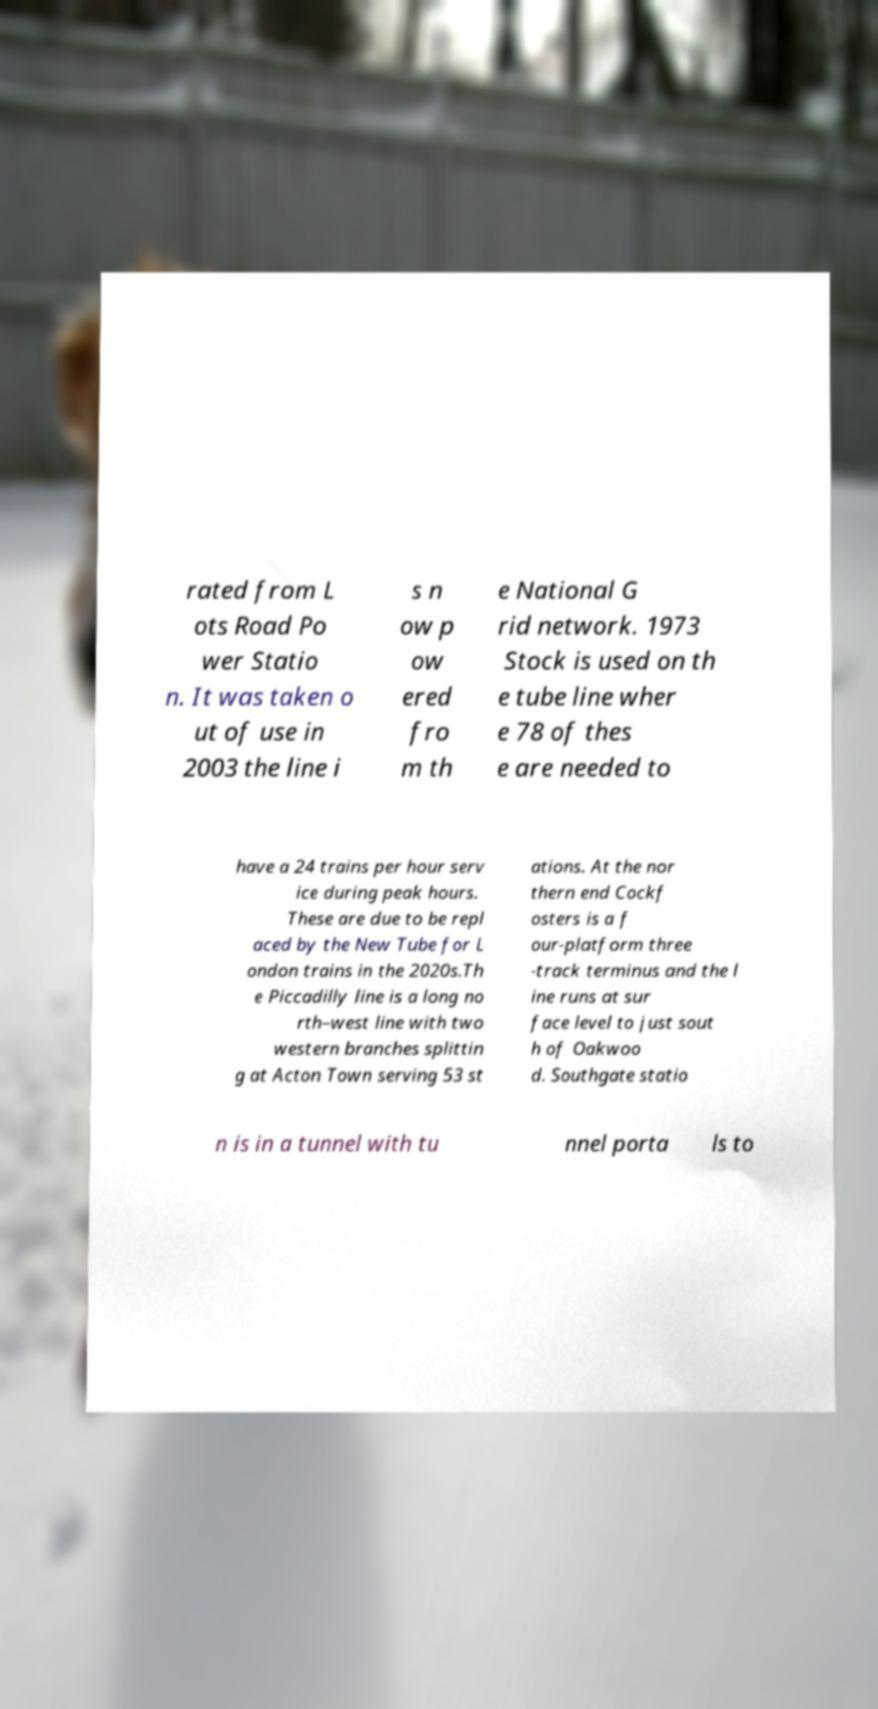There's text embedded in this image that I need extracted. Can you transcribe it verbatim? rated from L ots Road Po wer Statio n. It was taken o ut of use in 2003 the line i s n ow p ow ered fro m th e National G rid network. 1973 Stock is used on th e tube line wher e 78 of thes e are needed to have a 24 trains per hour serv ice during peak hours. These are due to be repl aced by the New Tube for L ondon trains in the 2020s.Th e Piccadilly line is a long no rth–west line with two western branches splittin g at Acton Town serving 53 st ations. At the nor thern end Cockf osters is a f our-platform three -track terminus and the l ine runs at sur face level to just sout h of Oakwoo d. Southgate statio n is in a tunnel with tu nnel porta ls to 